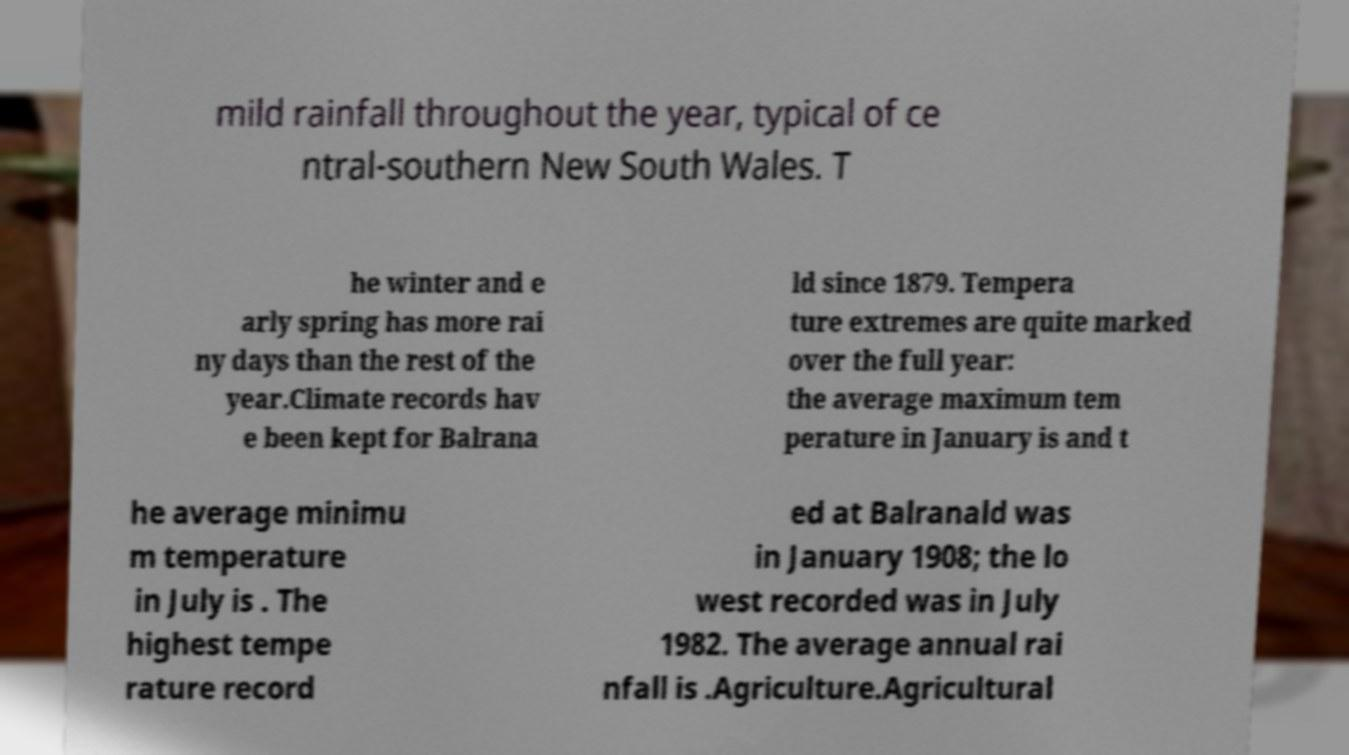For documentation purposes, I need the text within this image transcribed. Could you provide that? mild rainfall throughout the year, typical of ce ntral-southern New South Wales. T he winter and e arly spring has more rai ny days than the rest of the year.Climate records hav e been kept for Balrana ld since 1879. Tempera ture extremes are quite marked over the full year: the average maximum tem perature in January is and t he average minimu m temperature in July is . The highest tempe rature record ed at Balranald was in January 1908; the lo west recorded was in July 1982. The average annual rai nfall is .Agriculture.Agricultural 